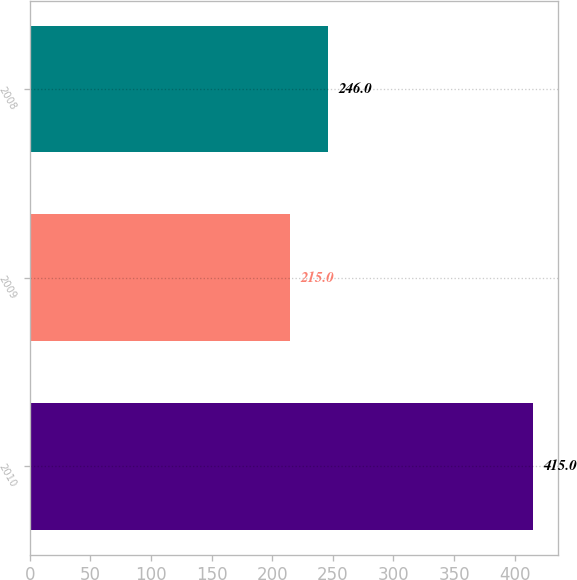Convert chart. <chart><loc_0><loc_0><loc_500><loc_500><bar_chart><fcel>2010<fcel>2009<fcel>2008<nl><fcel>415<fcel>215<fcel>246<nl></chart> 